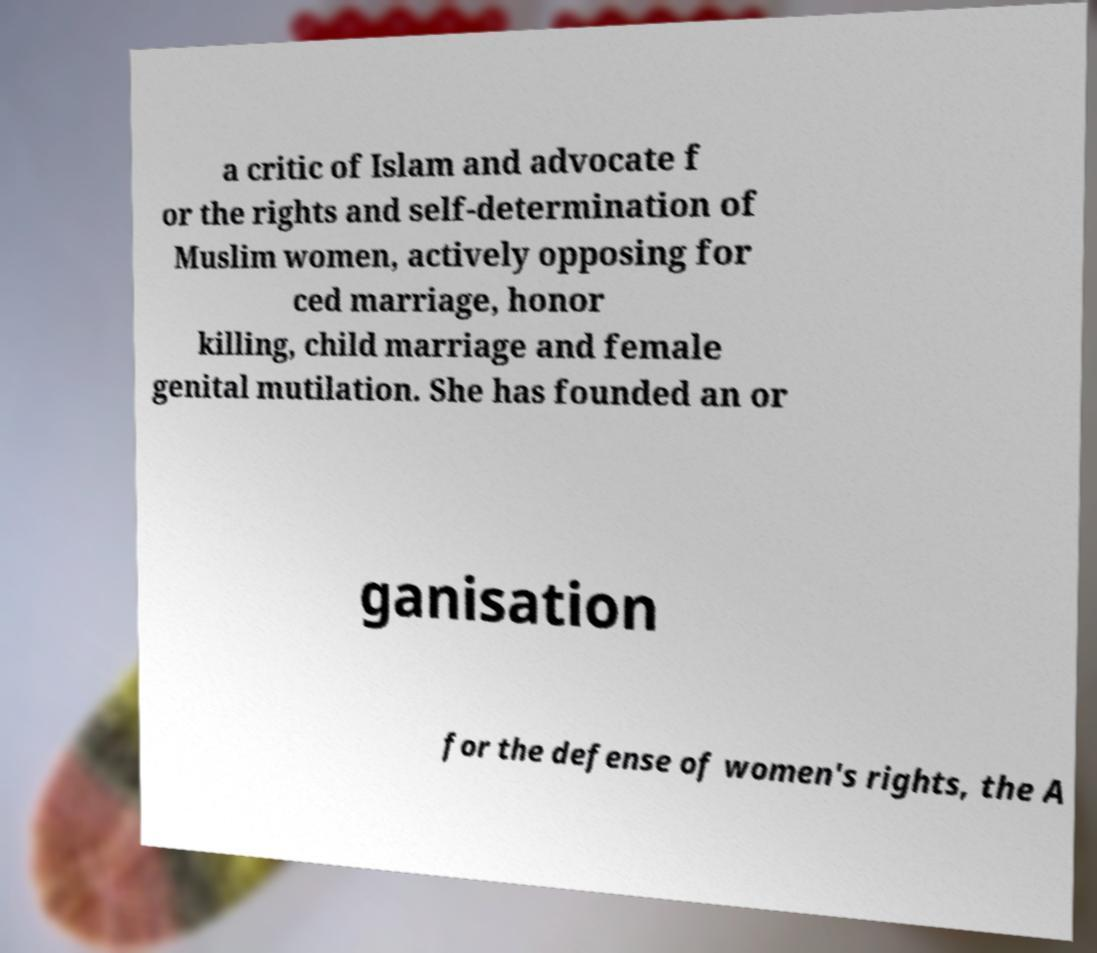Please identify and transcribe the text found in this image. a critic of Islam and advocate f or the rights and self-determination of Muslim women, actively opposing for ced marriage, honor killing, child marriage and female genital mutilation. She has founded an or ganisation for the defense of women's rights, the A 